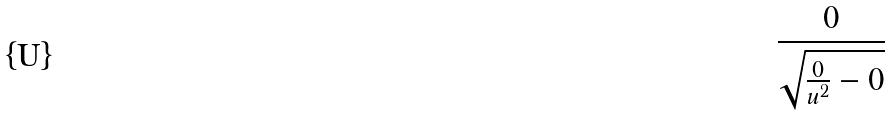<formula> <loc_0><loc_0><loc_500><loc_500>\frac { 0 } { \sqrt { \frac { 0 } { u ^ { 2 } } - 0 } }</formula> 